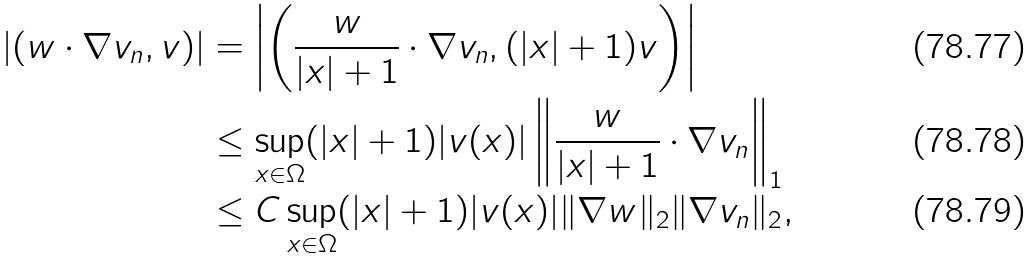<formula> <loc_0><loc_0><loc_500><loc_500>| ( w \cdot \nabla v _ { n } , v ) | & = \left | \left ( \frac { w } { | x | + 1 } \cdot \nabla v _ { n } , ( | x | + 1 ) v \right ) \right | \\ & \leq \sup _ { x \in \Omega } ( | x | + 1 ) | v ( x ) | \left \| \frac { w } { | x | + 1 } \cdot \nabla v _ { n } \right \| _ { 1 } \\ & \leq C \sup _ { x \in \Omega } ( | x | + 1 ) | v ( x ) | \| \nabla w \| _ { 2 } \| \nabla v _ { n } \| _ { 2 } ,</formula> 